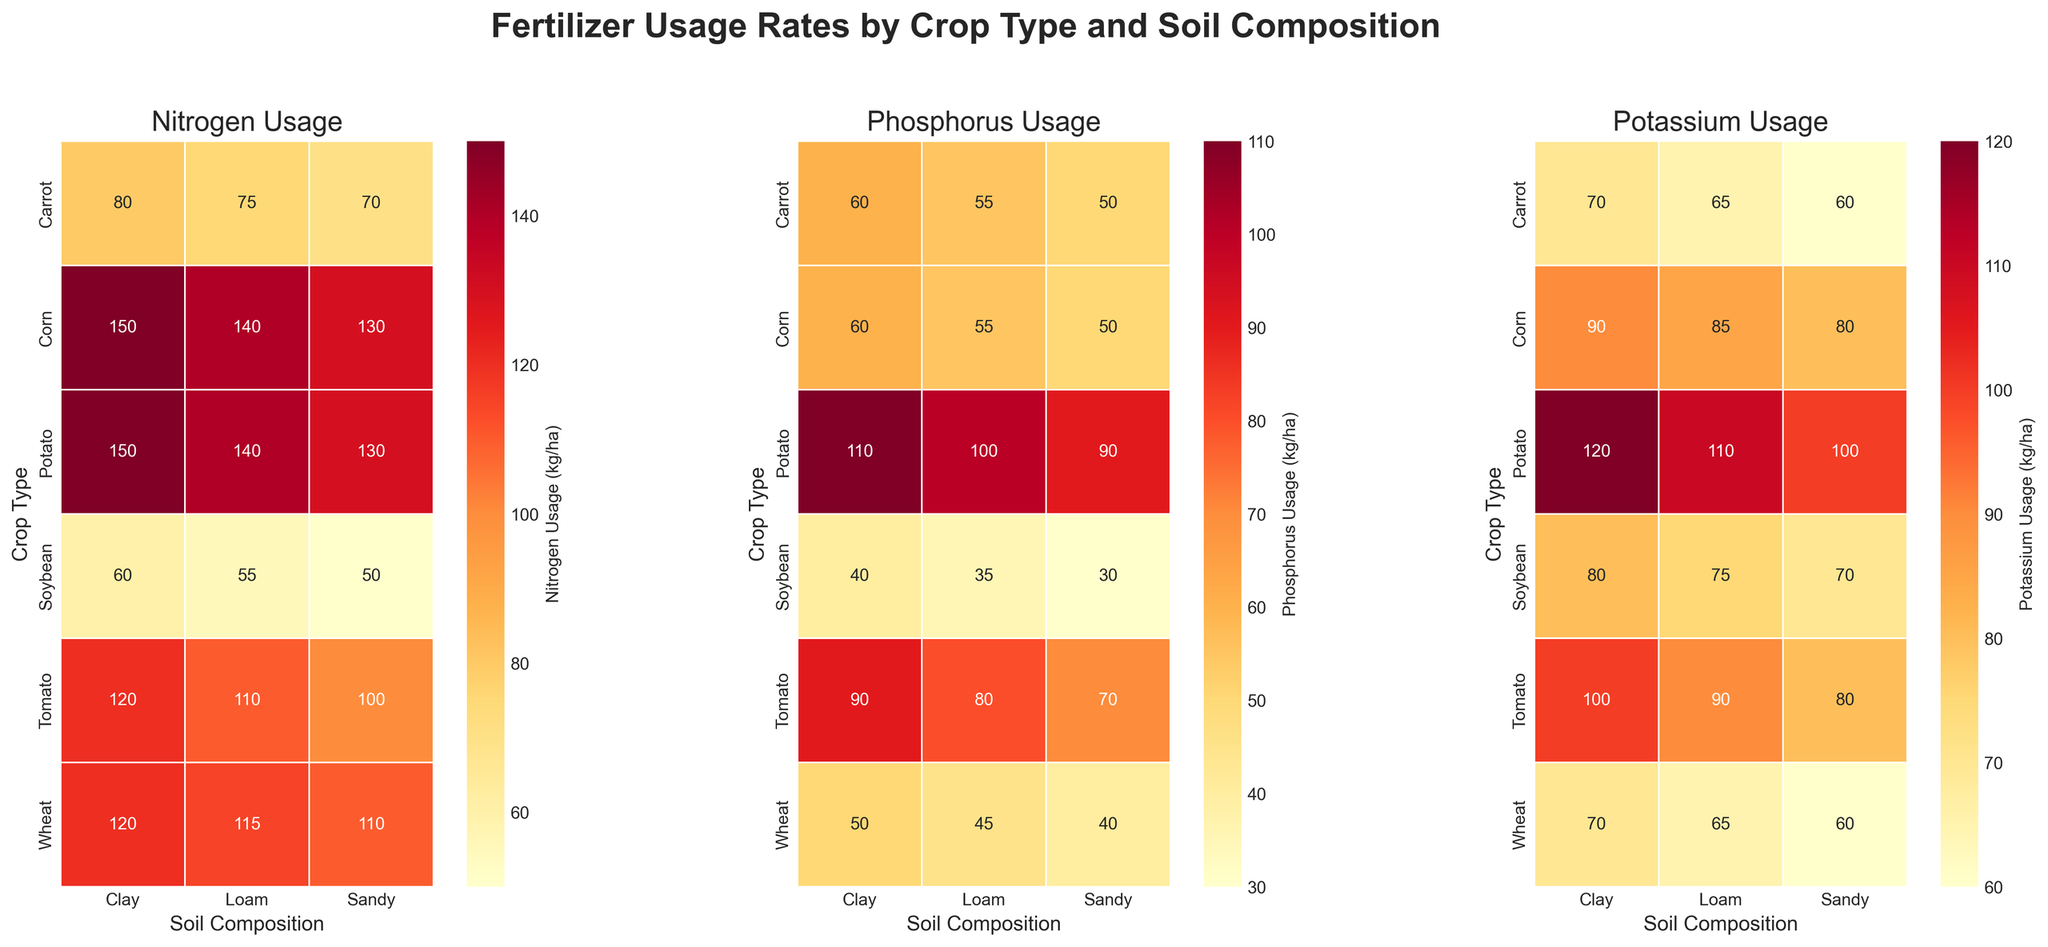Which crop type uses the most nitrogen on clay soil? Check the Nitrogen Usage heatmap and find the cell for Clay soil in the Nitrogen Usage grid. The crop with the highest number in this column is Potato at 150 kg/ha.
Answer: Potato What is the average phosphorus usage for corn across all soil types? Look at the Phosphorus Usage heatmap and find the values for Corn: Clay (60), Loam (55), Sandy (50). Sum these values (60 + 55 + 50 = 165) and then divide by the number of soil types (3) to find the average.
Answer: 55 Which soil composition generally results in the lowest potassium usage across all crops? Compare the numbers across each row for each soil type in the Potassium Usage heatmap. Sandy soil consistently has the lowest values compared to Clay and Loam soils.
Answer: Sandy How does the nitrogen usage for tomato on sandy soil compare to corn on clay soil? Check the Nitrogen Usage heatmap for both cells. Tomato (Sandy Soil) has 100 kg/ha, and Corn (Clay Soil) has 150 kg/ha. Tomato uses 50 kg/ha less nitrogen.
Answer: Tomato uses 50 kg/ha less Which crop type shows the highest phosphorus usage on loam soil, and what is the value? In the Phosphorus Usage heatmap, find the highest value in the Loam column. The highest value is for Potato at 100 kg/ha.
Answer: Potato, 100 kg/ha 